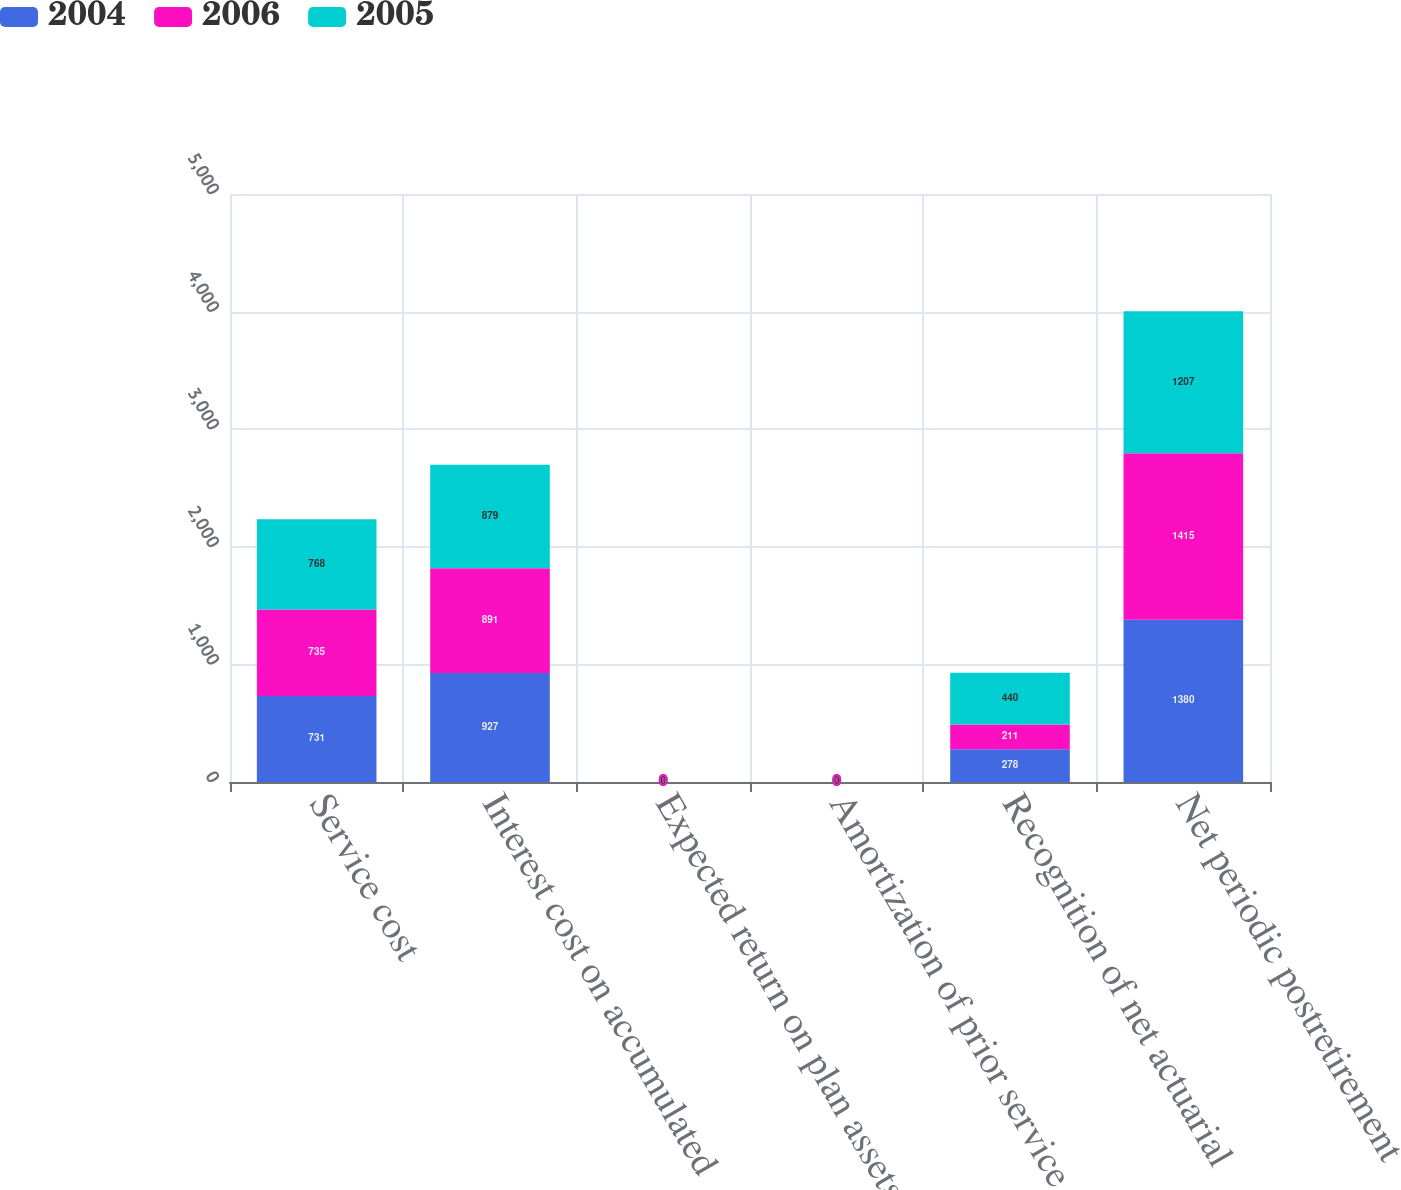Convert chart to OTSL. <chart><loc_0><loc_0><loc_500><loc_500><stacked_bar_chart><ecel><fcel>Service cost<fcel>Interest cost on accumulated<fcel>Expected return on plan assets<fcel>Amortization of prior service<fcel>Recognition of net actuarial<fcel>Net periodic postretirement<nl><fcel>2004<fcel>731<fcel>927<fcel>0<fcel>0<fcel>278<fcel>1380<nl><fcel>2006<fcel>735<fcel>891<fcel>0<fcel>0<fcel>211<fcel>1415<nl><fcel>2005<fcel>768<fcel>879<fcel>0<fcel>0<fcel>440<fcel>1207<nl></chart> 